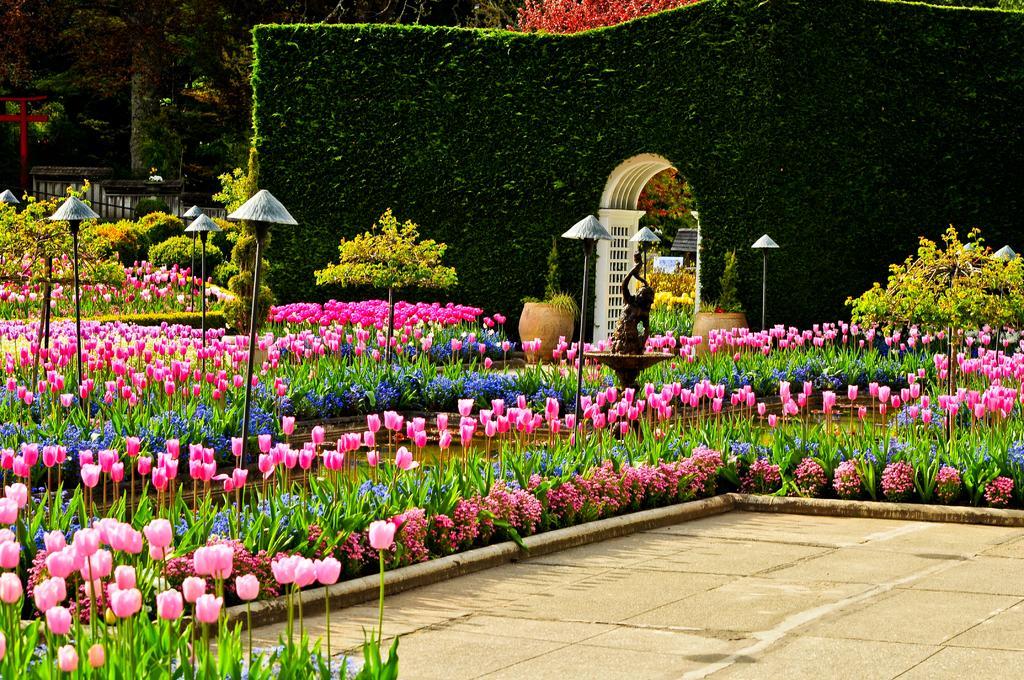How would you summarize this image in a sentence or two? In this image I can see the ground, few plants which are green in color, few flowers which are pink and purple in color, few poles and a statue. In the background I can see few trees, 